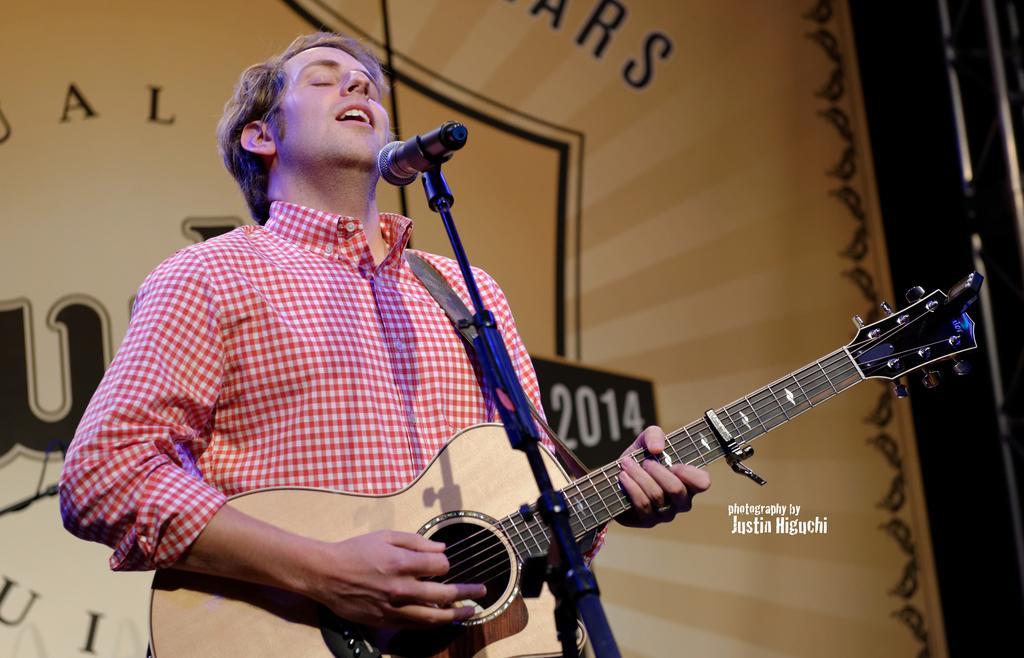Can you describe this image briefly? In the image we can see there is a man who is standing and holding guitar in his hand. 